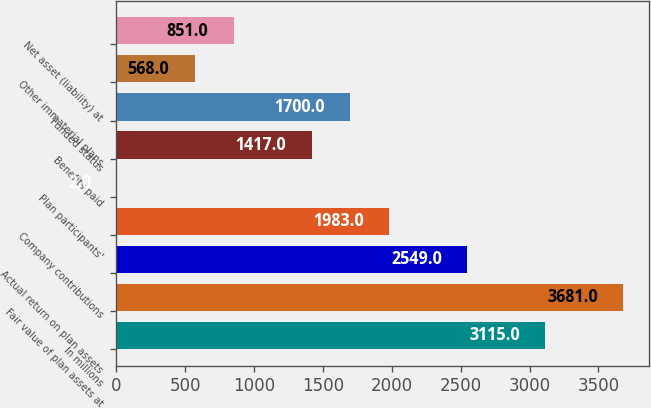Convert chart to OTSL. <chart><loc_0><loc_0><loc_500><loc_500><bar_chart><fcel>In millions<fcel>Fair value of plan assets at<fcel>Actual return on plan assets<fcel>Company contributions<fcel>Plan participants'<fcel>Benefits paid<fcel>Funded status<fcel>Other immaterial plans<fcel>Net asset (liability) at<nl><fcel>3115<fcel>3681<fcel>2549<fcel>1983<fcel>2<fcel>1417<fcel>1700<fcel>568<fcel>851<nl></chart> 